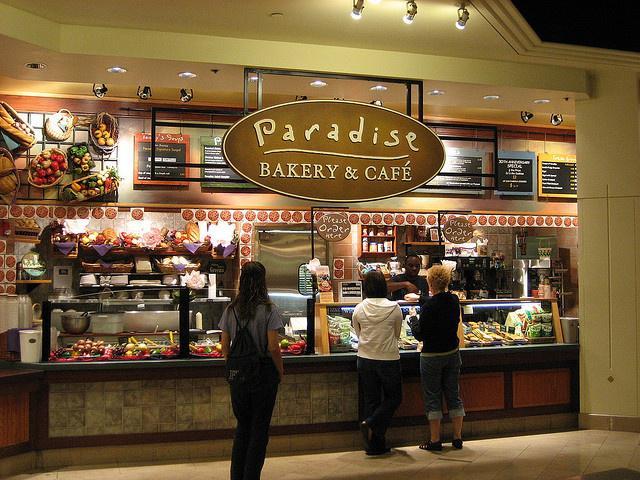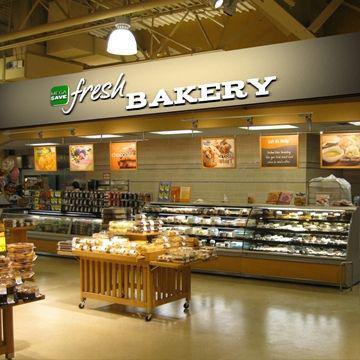The first image is the image on the left, the second image is the image on the right. Considering the images on both sides, is "An image includes a person behind a bakery counter and at least one back-turned person standing in front of the counter." valid? Answer yes or no. Yes. The first image is the image on the left, the second image is the image on the right. For the images displayed, is the sentence "There are three customers waiting at the bakery counter." factually correct? Answer yes or no. Yes. 